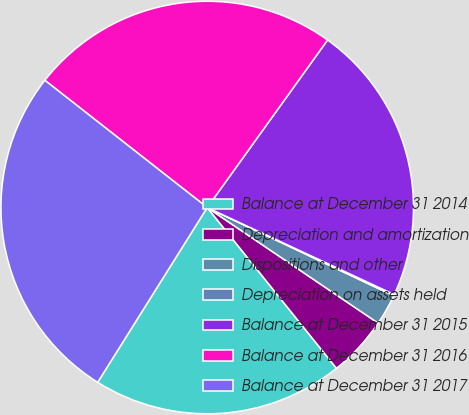<chart> <loc_0><loc_0><loc_500><loc_500><pie_chart><fcel>Balance at December 31 2014<fcel>Depreciation and amortization<fcel>Dispositions and other<fcel>Depreciation on assets held<fcel>Balance at December 31 2015<fcel>Balance at December 31 2016<fcel>Balance at December 31 2017<nl><fcel>19.69%<fcel>4.76%<fcel>2.43%<fcel>0.1%<fcel>22.02%<fcel>24.34%<fcel>26.67%<nl></chart> 